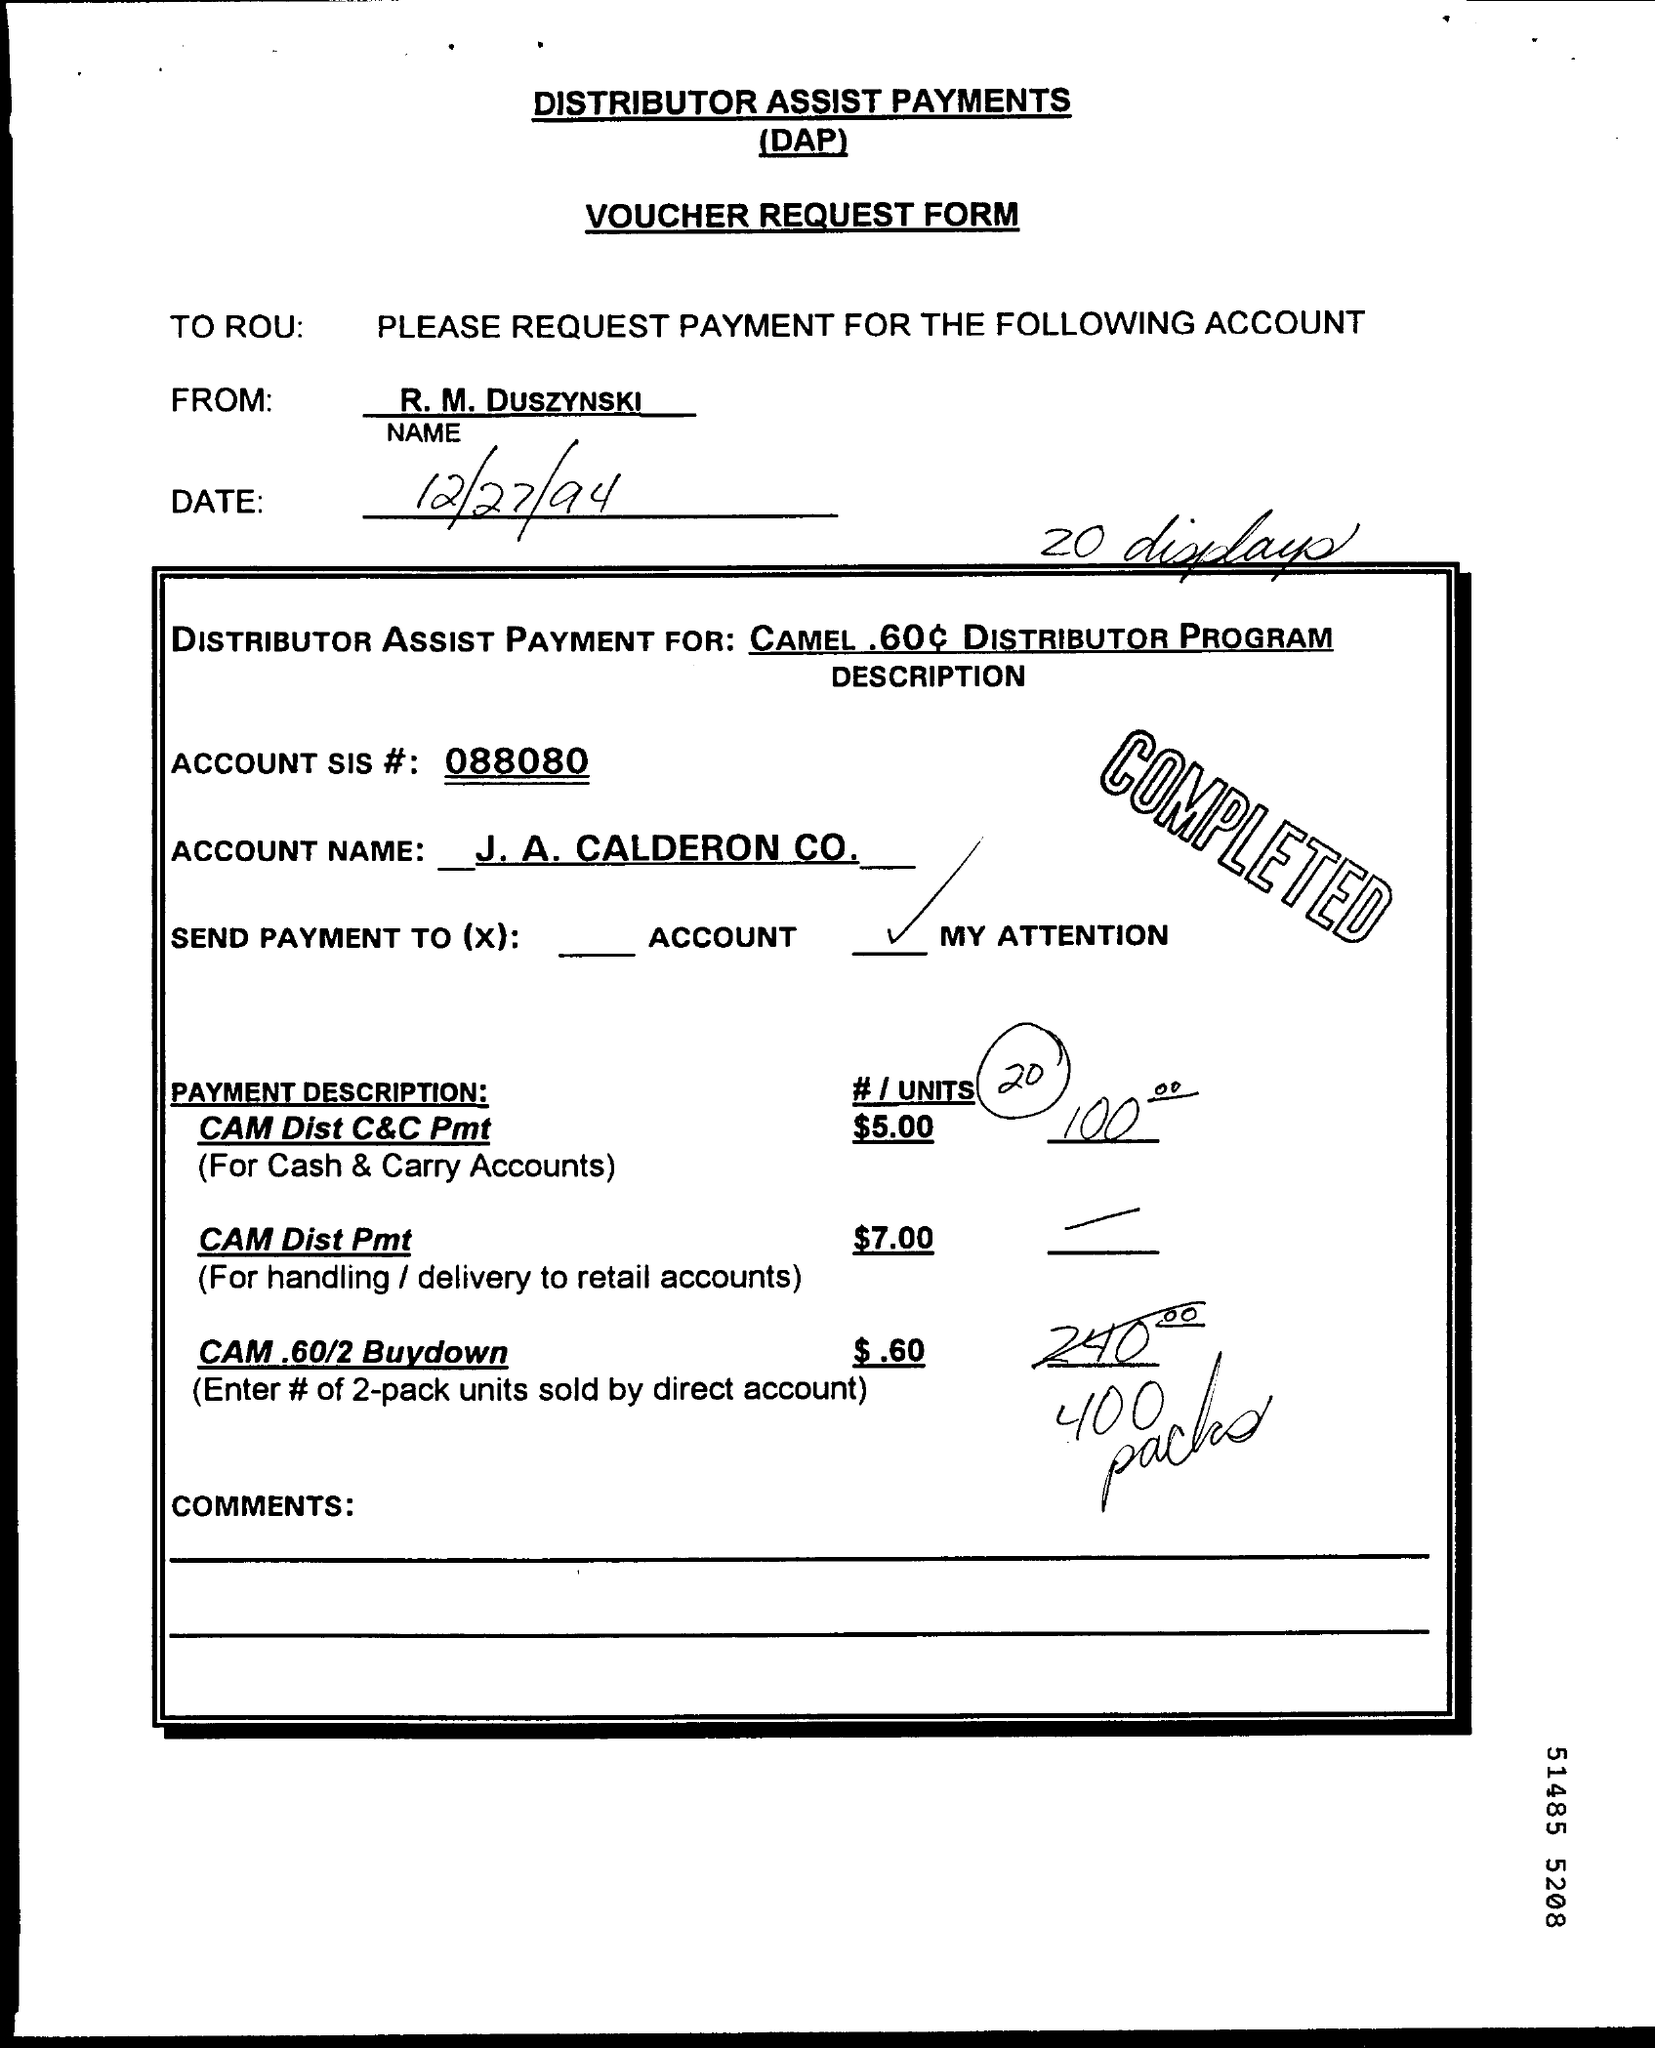What is the full form of DAP
Your answer should be very brief. DISTRIBUTOR ASSIST PAYMENTS. What is the name of this form
Ensure brevity in your answer.  VOUCHER REQUEST FORM. 